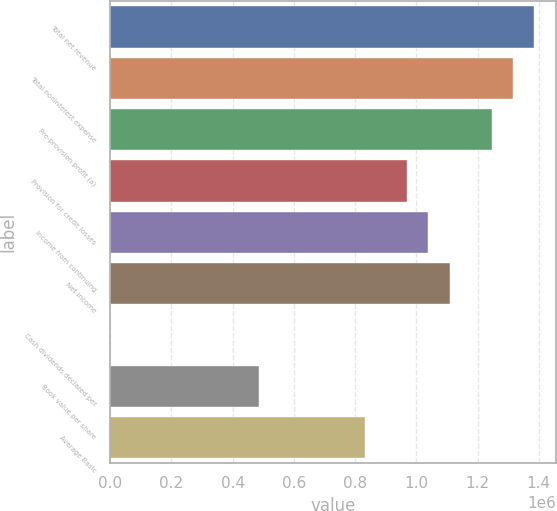Convert chart. <chart><loc_0><loc_0><loc_500><loc_500><bar_chart><fcel>Total net revenue<fcel>Total noninterest expense<fcel>Pre-provision profit (a)<fcel>Provision for credit losses<fcel>Income from continuing<fcel>Net income<fcel>Cash dividends declared per<fcel>Book value per share<fcel>Average Basic<nl><fcel>1.38585e+06<fcel>1.31656e+06<fcel>1.24727e+06<fcel>970098<fcel>1.03939e+06<fcel>1.10868e+06<fcel>0.2<fcel>485049<fcel>831512<nl></chart> 